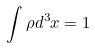Convert formula to latex. <formula><loc_0><loc_0><loc_500><loc_500>\int \rho d ^ { 3 } x = 1</formula> 